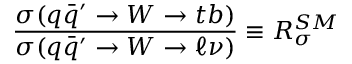Convert formula to latex. <formula><loc_0><loc_0><loc_500><loc_500>{ \frac { \sigma ( q \bar { q } ^ { \prime } \to W \to t b ) } { \sigma ( q \bar { q } ^ { \prime } \to W \to \ell \nu ) } } \equiv R _ { \sigma } ^ { S M }</formula> 